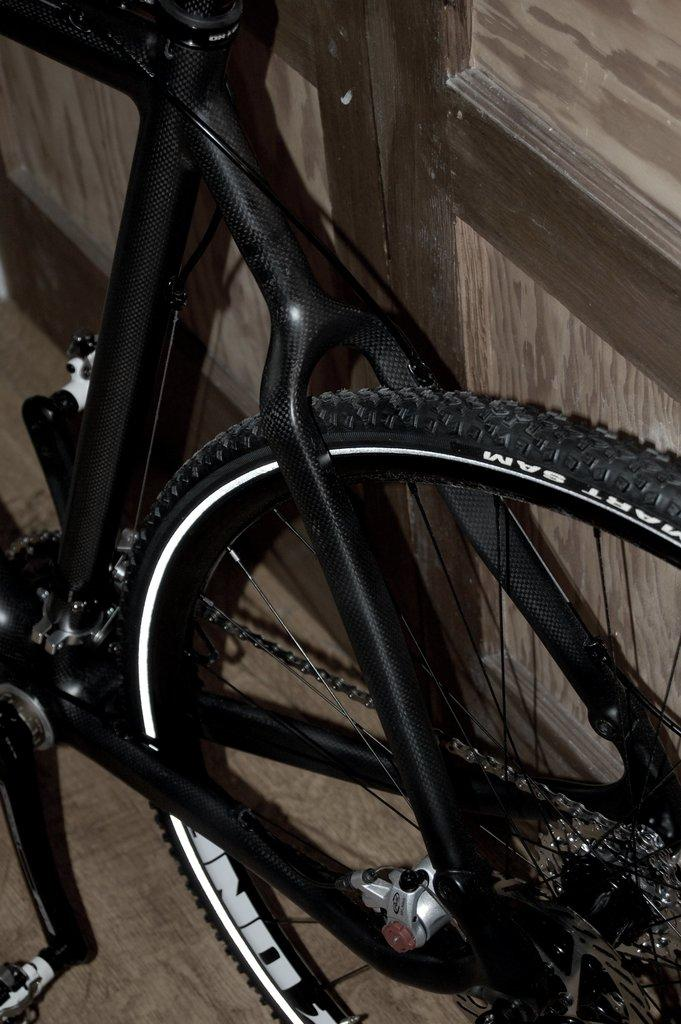What is the main object in the image? There is a bicycle in the image. What is the bicycle placed on? The bicycle is placed on a wooden surface. Can you describe any other wooden objects in the image? There is a wooden board on the right side of the image. What type of soap is being used to clean the bicycle in the image? There is no soap or cleaning activity depicted in the image; it only shows a bicycle placed on a wooden surface and a wooden board on the right side. 